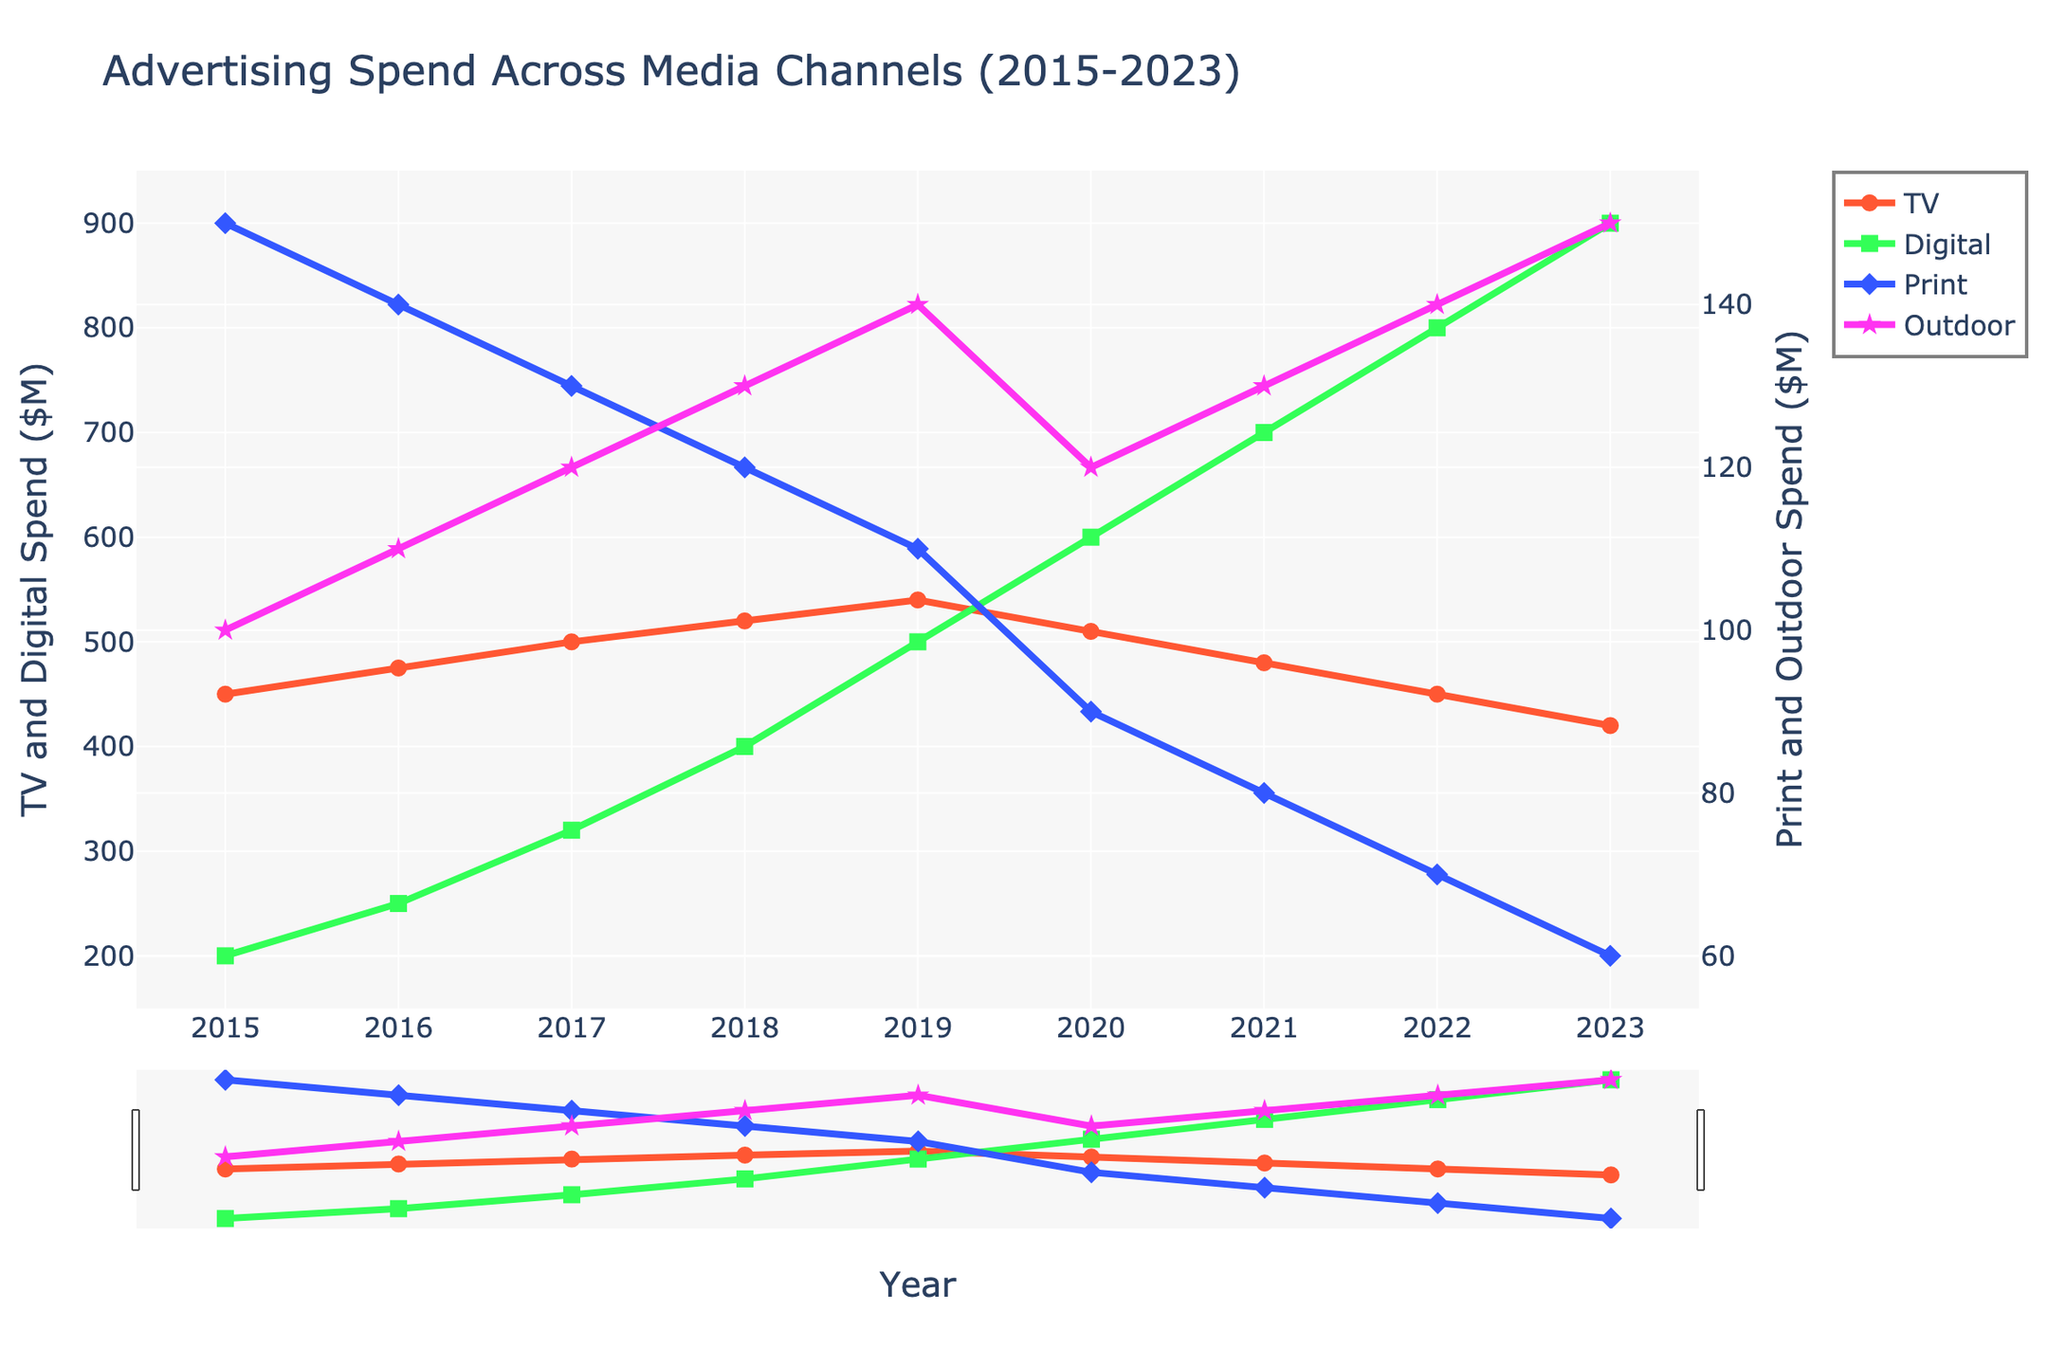What is the overall trend in TV advertising spend from 2015 to 2023? The TV advertising spend starts at $450M in 2015 and shows a gradual increase up to $540M by 2019. After 2019, there is a decline each year, reaching $420M in 2023.
Answer: It increases until 2019 then decreases How does the spending on Digital advertising in 2020 compare to 2023? In 2020, the Digital spend is $600M, whereas it increases to $900M by 2023. This is an increase of $300M from 2020 to 2023.
Answer: It increased by $300M What was the total combined advertising spend of TV and Digital in 2017? The TV spend in 2017 is $500M, and the Digital spend is $320M, so the combined total is $500M + $320M = $820M.
Answer: $820M Which media channel saw the most significant decrease in spend from 2015 to 2023? TV saw a decrease from $450M in 2015 to $420M in 2023, Digital increased, Print decreased from $150M to $60M, and Outdoor increased. Print saw the most significant decrease of $90M.
Answer: Print Between which years did the Outdoor advertising spend increase the most? From observing the points, it seems that the largest increase in Outdoor spend happened between 2022 and 2023, where it increased from $140M to $150M, an increase of $10M.
Answer: 2022 to 2023 In 2021, what was the collective advertising spend on Print and Outdoor? The Print spend in 2021 is $80M and the Outdoor spend is $130M. The total for both is $80M + $130M = $210M.
Answer: $210M When was Digital advertising spend higher than TV advertising spend? Starting from 2018, Digital advertising spend surpasses TV advertising spend, and this trend continues each year thereafter.
Answer: From 2018 onwards What is the average annual spending on Print advertising from 2015 to 2023? The annual spends are $150M, $140M, $130M, $120M, $110M, $90M, $80M, $70M, and $60M. Summing these gives:  $150M + $140M + $130M + $120M + $110M + $90M + $80M + $70M + $60M = $950M. Dividing by 9 gives: $950M / 9 ≈ $105.56M.
Answer: $105.56M Which two media channels showed an opposite trend in their spending patterns over the years? Digital and Print showed opposite trends. Digital spend continuously increased from $200M to $900M, while Print continuously decreased from $150M to $60M.
Answer: Digital and Print 